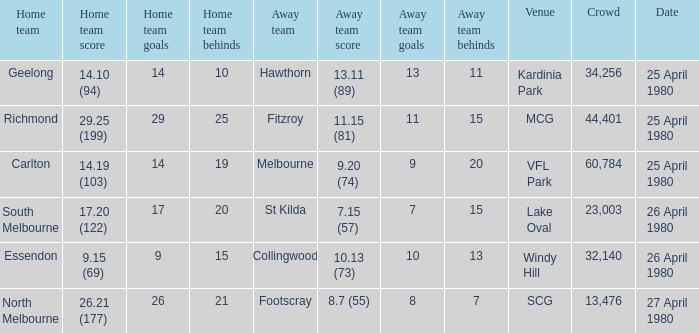Write the full table. {'header': ['Home team', 'Home team score', 'Home team goals', 'Home team behinds', 'Away team', 'Away team score', 'Away team goals', 'Away team behinds', 'Venue', 'Crowd', 'Date'], 'rows': [['Geelong', '14.10 (94)', '14', '10', 'Hawthorn', '13.11 (89)', '13', '11', 'Kardinia Park', '34,256', '25 April 1980'], ['Richmond', '29.25 (199)', '29', '25', 'Fitzroy', '11.15 (81)', '11', '15', 'MCG', '44,401', '25 April 1980'], ['Carlton', '14.19 (103)', '14', '19', 'Melbourne', '9.20 (74)', '9', '20', 'VFL Park', '60,784', '25 April 1980'], ['South Melbourne', '17.20 (122)', '17', '20', 'St Kilda', '7.15 (57)', '7', '15', 'Lake Oval', '23,003', '26 April 1980'], ['Essendon', '9.15 (69)', '9', '15', 'Collingwood', '10.13 (73)', '10', '13', 'Windy Hill', '32,140', '26 April 1980'], ['North Melbourne', '26.21 (177)', '26', '21', 'Footscray', '8.7 (55)', '8', '7', 'SCG', '13,476', '27 April 1980']]} What was the lowest crowd size at MCG? 44401.0. 